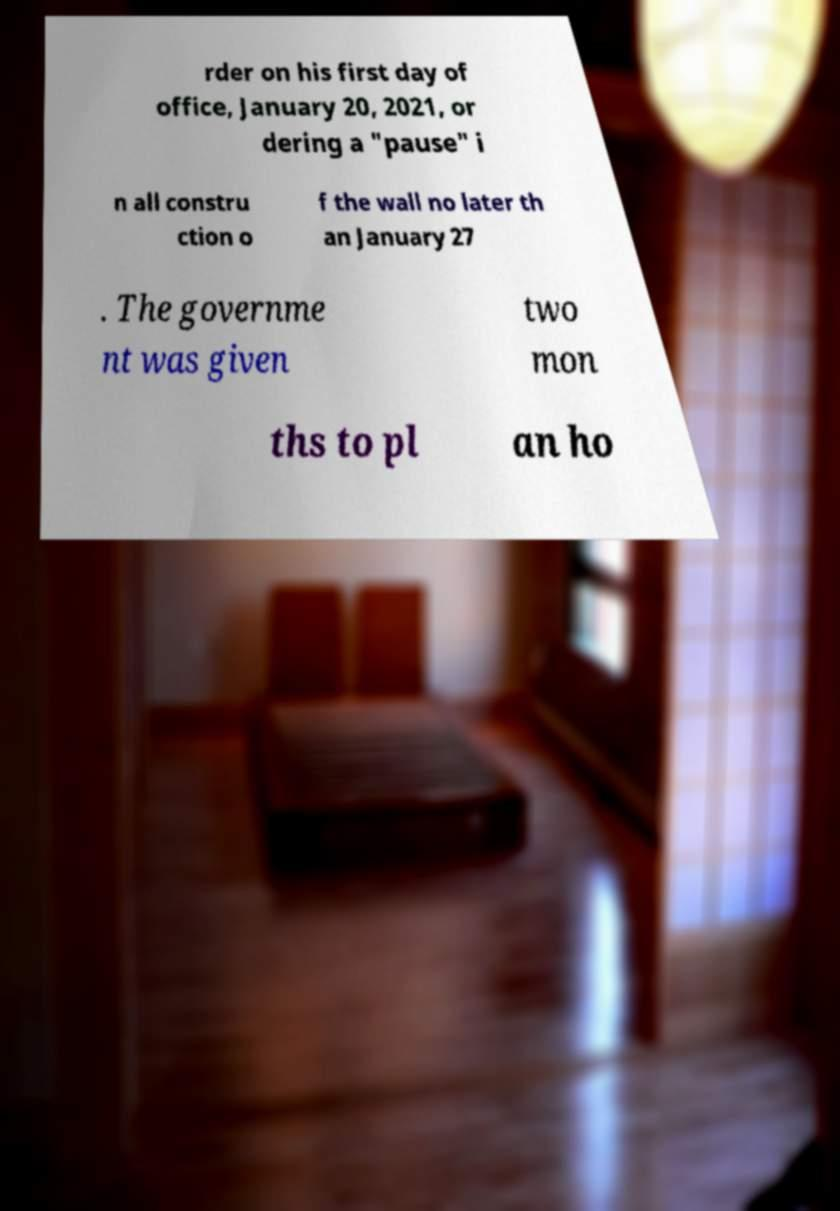Could you assist in decoding the text presented in this image and type it out clearly? rder on his first day of office, January 20, 2021, or dering a "pause" i n all constru ction o f the wall no later th an January 27 . The governme nt was given two mon ths to pl an ho 